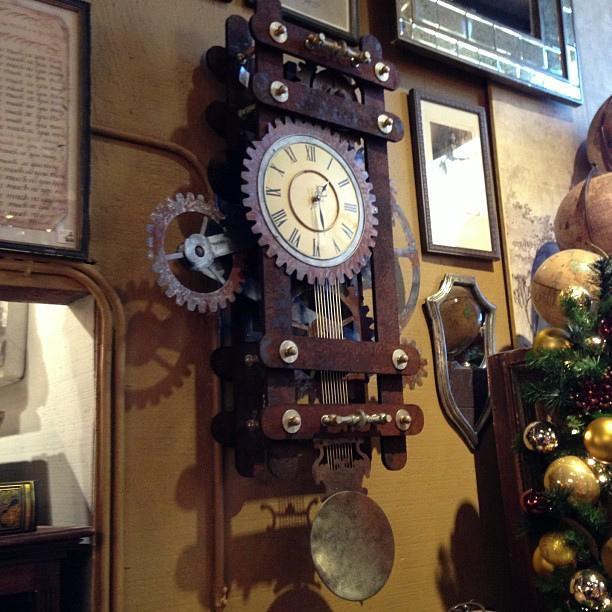How many clocks are on the wall?
Give a very brief answer. 1. How many clocks are in the picture?
Give a very brief answer. 1. 